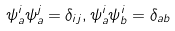Convert formula to latex. <formula><loc_0><loc_0><loc_500><loc_500>\psi _ { a } ^ { i } \psi _ { a } ^ { j } = \delta _ { i j } , \psi _ { a } ^ { i } \psi _ { b } ^ { i } = \delta _ { a b }</formula> 